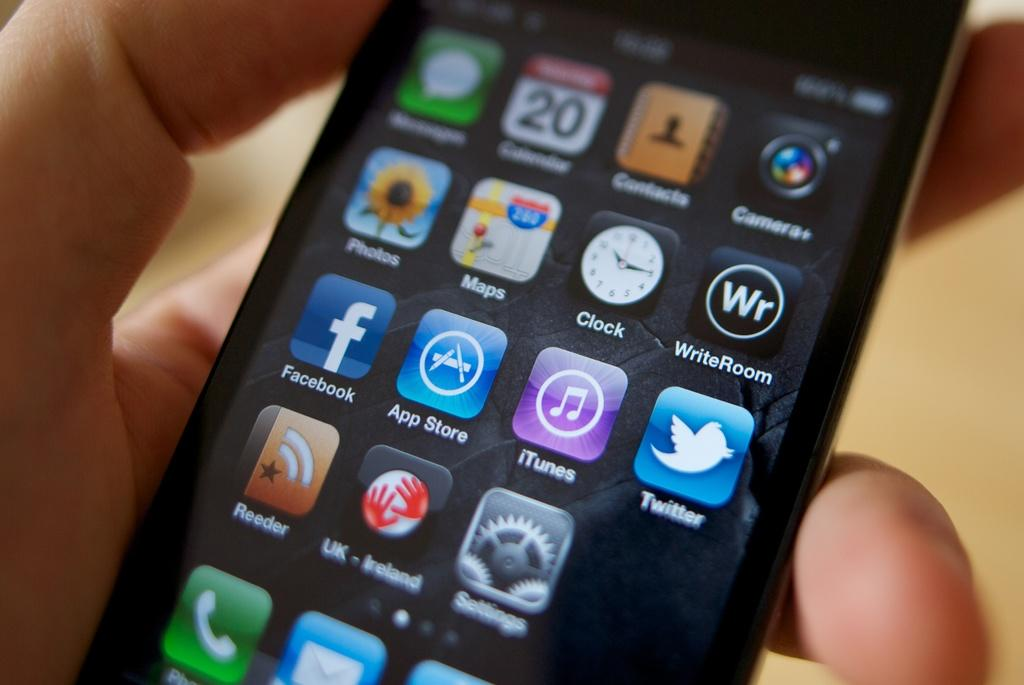Provide a one-sentence caption for the provided image. A person is holding a cell phone that shows that it is the 20th day of the month. 